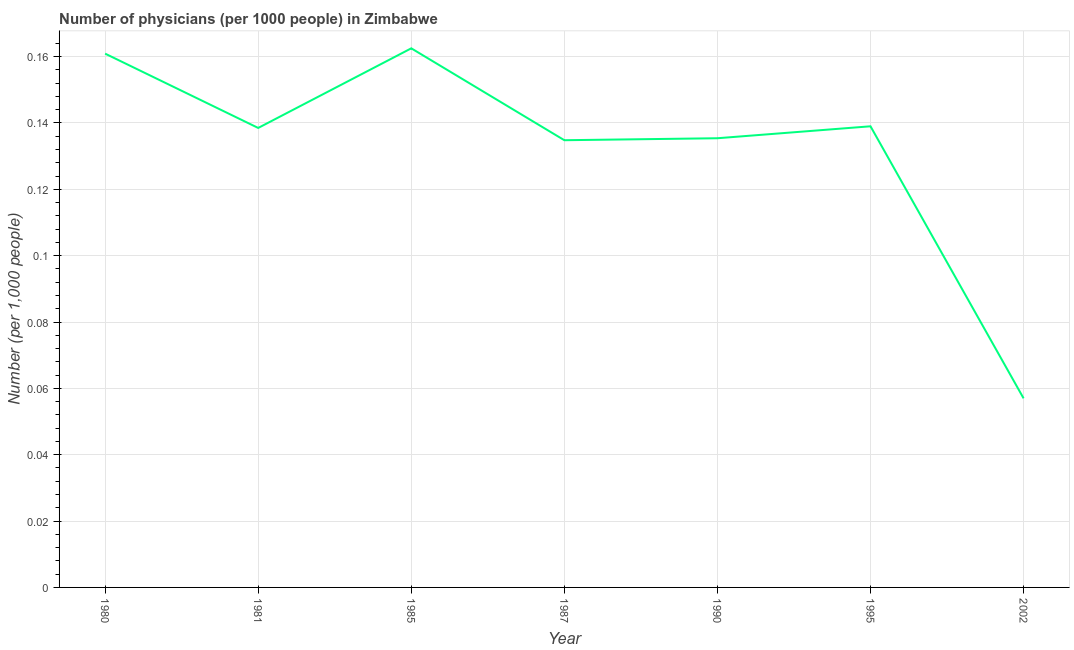What is the number of physicians in 1987?
Your response must be concise. 0.13. Across all years, what is the maximum number of physicians?
Keep it short and to the point. 0.16. Across all years, what is the minimum number of physicians?
Your response must be concise. 0.06. In which year was the number of physicians minimum?
Provide a succinct answer. 2002. What is the sum of the number of physicians?
Offer a very short reply. 0.93. What is the difference between the number of physicians in 1985 and 1987?
Provide a short and direct response. 0.03. What is the average number of physicians per year?
Offer a very short reply. 0.13. What is the median number of physicians?
Your answer should be compact. 0.14. In how many years, is the number of physicians greater than 0.092 ?
Your answer should be compact. 6. What is the ratio of the number of physicians in 1985 to that in 1995?
Keep it short and to the point. 1.17. Is the number of physicians in 1990 less than that in 2002?
Provide a short and direct response. No. What is the difference between the highest and the second highest number of physicians?
Provide a succinct answer. 0. What is the difference between the highest and the lowest number of physicians?
Give a very brief answer. 0.11. Does the number of physicians monotonically increase over the years?
Make the answer very short. No. What is the difference between two consecutive major ticks on the Y-axis?
Provide a succinct answer. 0.02. What is the title of the graph?
Make the answer very short. Number of physicians (per 1000 people) in Zimbabwe. What is the label or title of the X-axis?
Your answer should be compact. Year. What is the label or title of the Y-axis?
Offer a terse response. Number (per 1,0 people). What is the Number (per 1,000 people) in 1980?
Make the answer very short. 0.16. What is the Number (per 1,000 people) in 1981?
Keep it short and to the point. 0.14. What is the Number (per 1,000 people) in 1985?
Your answer should be compact. 0.16. What is the Number (per 1,000 people) in 1987?
Offer a very short reply. 0.13. What is the Number (per 1,000 people) in 1990?
Your response must be concise. 0.14. What is the Number (per 1,000 people) in 1995?
Your answer should be compact. 0.14. What is the Number (per 1,000 people) in 2002?
Give a very brief answer. 0.06. What is the difference between the Number (per 1,000 people) in 1980 and 1981?
Keep it short and to the point. 0.02. What is the difference between the Number (per 1,000 people) in 1980 and 1985?
Your answer should be very brief. -0. What is the difference between the Number (per 1,000 people) in 1980 and 1987?
Your answer should be very brief. 0.03. What is the difference between the Number (per 1,000 people) in 1980 and 1990?
Your answer should be very brief. 0.03. What is the difference between the Number (per 1,000 people) in 1980 and 1995?
Ensure brevity in your answer.  0.02. What is the difference between the Number (per 1,000 people) in 1980 and 2002?
Offer a very short reply. 0.1. What is the difference between the Number (per 1,000 people) in 1981 and 1985?
Keep it short and to the point. -0.02. What is the difference between the Number (per 1,000 people) in 1981 and 1987?
Offer a very short reply. 0. What is the difference between the Number (per 1,000 people) in 1981 and 1990?
Ensure brevity in your answer.  0. What is the difference between the Number (per 1,000 people) in 1981 and 1995?
Provide a short and direct response. -0. What is the difference between the Number (per 1,000 people) in 1981 and 2002?
Offer a terse response. 0.08. What is the difference between the Number (per 1,000 people) in 1985 and 1987?
Your answer should be very brief. 0.03. What is the difference between the Number (per 1,000 people) in 1985 and 1990?
Keep it short and to the point. 0.03. What is the difference between the Number (per 1,000 people) in 1985 and 1995?
Offer a terse response. 0.02. What is the difference between the Number (per 1,000 people) in 1985 and 2002?
Keep it short and to the point. 0.11. What is the difference between the Number (per 1,000 people) in 1987 and 1990?
Your response must be concise. -0. What is the difference between the Number (per 1,000 people) in 1987 and 1995?
Keep it short and to the point. -0. What is the difference between the Number (per 1,000 people) in 1987 and 2002?
Offer a terse response. 0.08. What is the difference between the Number (per 1,000 people) in 1990 and 1995?
Ensure brevity in your answer.  -0. What is the difference between the Number (per 1,000 people) in 1990 and 2002?
Give a very brief answer. 0.08. What is the difference between the Number (per 1,000 people) in 1995 and 2002?
Your answer should be very brief. 0.08. What is the ratio of the Number (per 1,000 people) in 1980 to that in 1981?
Provide a succinct answer. 1.16. What is the ratio of the Number (per 1,000 people) in 1980 to that in 1985?
Your answer should be compact. 0.99. What is the ratio of the Number (per 1,000 people) in 1980 to that in 1987?
Keep it short and to the point. 1.19. What is the ratio of the Number (per 1,000 people) in 1980 to that in 1990?
Give a very brief answer. 1.19. What is the ratio of the Number (per 1,000 people) in 1980 to that in 1995?
Provide a short and direct response. 1.16. What is the ratio of the Number (per 1,000 people) in 1980 to that in 2002?
Keep it short and to the point. 2.82. What is the ratio of the Number (per 1,000 people) in 1981 to that in 1985?
Keep it short and to the point. 0.85. What is the ratio of the Number (per 1,000 people) in 1981 to that in 1987?
Provide a succinct answer. 1.03. What is the ratio of the Number (per 1,000 people) in 1981 to that in 1990?
Offer a very short reply. 1.02. What is the ratio of the Number (per 1,000 people) in 1981 to that in 2002?
Make the answer very short. 2.43. What is the ratio of the Number (per 1,000 people) in 1985 to that in 1987?
Offer a very short reply. 1.21. What is the ratio of the Number (per 1,000 people) in 1985 to that in 1995?
Offer a terse response. 1.17. What is the ratio of the Number (per 1,000 people) in 1985 to that in 2002?
Your answer should be very brief. 2.85. What is the ratio of the Number (per 1,000 people) in 1987 to that in 1990?
Provide a short and direct response. 1. What is the ratio of the Number (per 1,000 people) in 1987 to that in 1995?
Provide a succinct answer. 0.97. What is the ratio of the Number (per 1,000 people) in 1987 to that in 2002?
Offer a terse response. 2.37. What is the ratio of the Number (per 1,000 people) in 1990 to that in 2002?
Your response must be concise. 2.38. What is the ratio of the Number (per 1,000 people) in 1995 to that in 2002?
Make the answer very short. 2.44. 